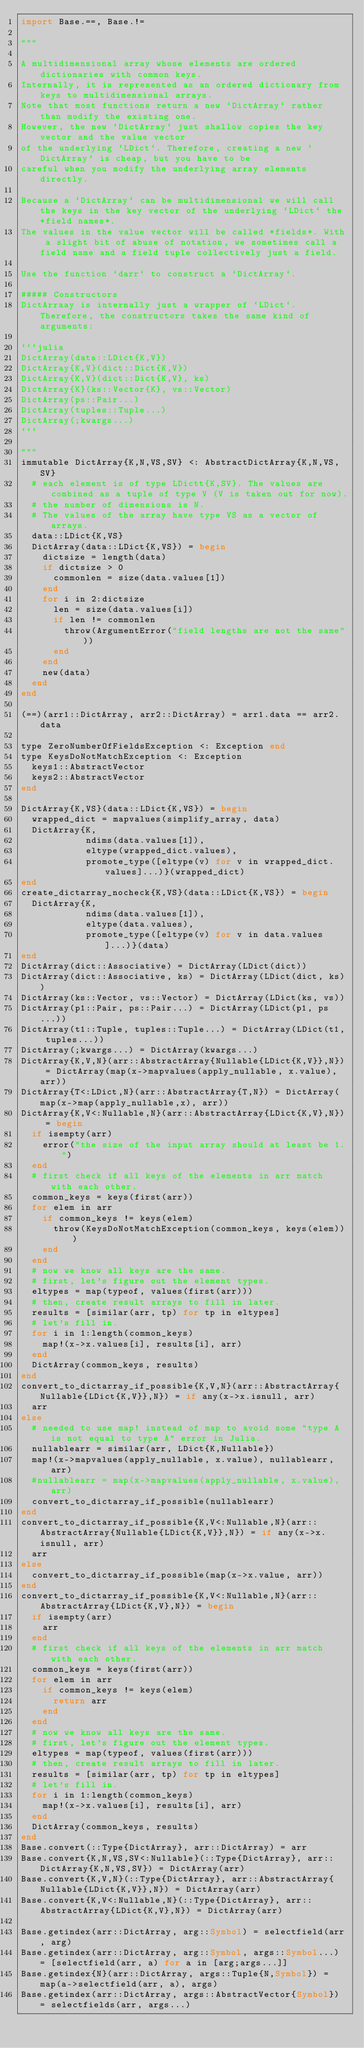<code> <loc_0><loc_0><loc_500><loc_500><_Julia_>import Base.==, Base.!=

"""

A multidimensional array whose elements are ordered dictionaries with common keys.
Internally, it is represented as an ordered dictionary from keys to multidimensional arrays.
Note that most functions return a new `DictArray` rather than modify the existing one.
However, the new `DictArray` just shallow copies the key vector and the value vector
of the underlying `LDict`. Therefore, creating a new `DictArray` is cheap, but you have to be
careful when you modify the underlying array elements directly.

Because a `DictArray` can be multidimensional we will call the keys in the key vector of the underlying `LDict` the *field names*.
The values in the value vector will be called *fields*. With a slight bit of abuse of notation, we sometimes call a field name and a field tuple collectively just a field.

Use the function `darr` to construct a `DictArray`.

##### Constructors
DictArraay is internally just a wrapper of `LDict`. Therefore, the constructors takes the same kind of arguments:

```julia
DictArray(data::LDict{K,V})
DictArray{K,V}(dict::Dict{K,V})
DictArray{K,V}(dict::Dict{K,V}, ks)
DictArray{K}(ks::Vector{K}, vs::Vector)
DictArray(ps::Pair...)
DictArray(tuples::Tuple...)
DictArray(;kwargs...)
```

"""
immutable DictArray{K,N,VS,SV} <: AbstractDictArray{K,N,VS,SV}
  # each element is of type LDictt{K,SV}. The values are combined as a tuple of type V (V is taken out for now).
  # the number of dimensions is N.
  # The values of the array have type VS as a vector of arrays.
  data::LDict{K,VS}
  DictArray(data::LDict{K,VS}) = begin
    dictsize = length(data)
    if dictsize > 0
      commonlen = size(data.values[1])
    end
    for i in 2:dictsize
      len = size(data.values[i])
      if len != commonlen
        throw(ArgumentError("field lengths are not the same"))
      end
    end
    new(data)
  end
end

(==)(arr1::DictArray, arr2::DictArray) = arr1.data == arr2.data

type ZeroNumberOfFieldsException <: Exception end
type KeysDoNotMatchException <: Exception
  keys1::AbstractVector
  keys2::AbstractVector
end

DictArray{K,VS}(data::LDict{K,VS}) = begin
  wrapped_dict = mapvalues(simplify_array, data)
  DictArray{K,
            ndims(data.values[1]),
            eltype(wrapped_dict.values),
            promote_type([eltype(v) for v in wrapped_dict.values]...)}(wrapped_dict)
end
create_dictarray_nocheck{K,VS}(data::LDict{K,VS}) = begin
  DictArray{K,
            ndims(data.values[1]),
            eltype(data.values),
            promote_type([eltype(v) for v in data.values]...)}(data)
end
DictArray(dict::Associative) = DictArray(LDict(dict))
DictArray(dict::Associative, ks) = DictArray(LDict(dict, ks))
DictArray(ks::Vector, vs::Vector) = DictArray(LDict(ks, vs))
DictArray(p1::Pair, ps::Pair...) = DictArray(LDict(p1, ps...))
DictArray(t1::Tuple, tuples::Tuple...) = DictArray(LDict(t1, tuples...))
DictArray(;kwargs...) = DictArray(kwargs...)
DictArray{K,V,N}(arr::AbstractArray{Nullable{LDict{K,V}},N}) = DictArray(map(x->mapvalues(apply_nullable, x.value), arr))
DictArray{T<:LDict,N}(arr::AbstractArray{T,N}) = DictArray(map(x->map(apply_nullable,x), arr))
DictArray{K,V<:Nullable,N}(arr::AbstractArray{LDict{K,V},N}) = begin
  if isempty(arr)
    error("the size of the input array should at least be 1.")
  end
  # first check if all keys of the elements in arr match with each other.
  common_keys = keys(first(arr))
  for elem in arr
    if common_keys != keys(elem)
      throw(KeysDoNotMatchException(common_keys, keys(elem)))
    end
  end
  # now we know all keys are the same.
  # first, let's figure out the element types.
  eltypes = map(typeof, values(first(arr)))
  # then, create result arrays to fill in later.
  results = [similar(arr, tp) for tp in eltypes]
  # let's fill in.
  for i in 1:length(common_keys)
    map!(x->x.values[i], results[i], arr)
  end
  DictArray(common_keys, results)
end
convert_to_dictarray_if_possible{K,V,N}(arr::AbstractArray{Nullable{LDict{K,V}},N}) = if any(x->x.isnull, arr)
  arr
else
  # needed to use map! instead of map to avoid some "type A is not equal to type A" error in Julia.
  nullablearr = similar(arr, LDict{K,Nullable})
  map!(x->mapvalues(apply_nullable, x.value), nullablearr, arr)
  #nullablearr = map(x->mapvalues(apply_nullable, x.value), arr)
  convert_to_dictarray_if_possible(nullablearr)
end
convert_to_dictarray_if_possible{K,V<:Nullable,N}(arr::AbstractArray{Nullable{LDict{K,V}},N}) = if any(x->x.isnull, arr)
  arr
else
  convert_to_dictarray_if_possible(map(x->x.value, arr))
end
convert_to_dictarray_if_possible{K,V<:Nullable,N}(arr::AbstractArray{LDict{K,V},N}) = begin
  if isempty(arr)
    arr
  end
  # first check if all keys of the elements in arr match with each other.
  common_keys = keys(first(arr))
  for elem in arr
    if common_keys != keys(elem)
      return arr
    end
  end
  # now we know all keys are the same.
  # first, let's figure out the element types.
  eltypes = map(typeof, values(first(arr)))
  # then, create result arrays to fill in later.
  results = [similar(arr, tp) for tp in eltypes]
  # let's fill in.
  for i in 1:length(common_keys)
    map!(x->x.values[i], results[i], arr)
  end
  DictArray(common_keys, results)
end
Base.convert(::Type{DictArray}, arr::DictArray) = arr
Base.convert{K,N,VS,SV<:Nullable}(::Type{DictArray}, arr::DictArray{K,N,VS,SV}) = DictArray(arr)
Base.convert{K,V,N}(::Type{DictArray}, arr::AbstractArray{Nullable{LDict{K,V}},N}) = DictArray(arr)
Base.convert{K,V<:Nullable,N}(::Type{DictArray}, arr::AbstractArray{LDict{K,V},N}) = DictArray(arr)

Base.getindex(arr::DictArray, arg::Symbol) = selectfield(arr, arg)
Base.getindex(arr::DictArray, arg::Symbol, args::Symbol...) = [selectfield(arr, a) for a in [arg;args...]]
Base.getindex{N}(arr::DictArray, args::Tuple{N,Symbol}) = map(a->selectfield(arr, a), args)
Base.getindex(arr::DictArray, args::AbstractVector{Symbol}) = selectfields(arr, args...)
</code> 